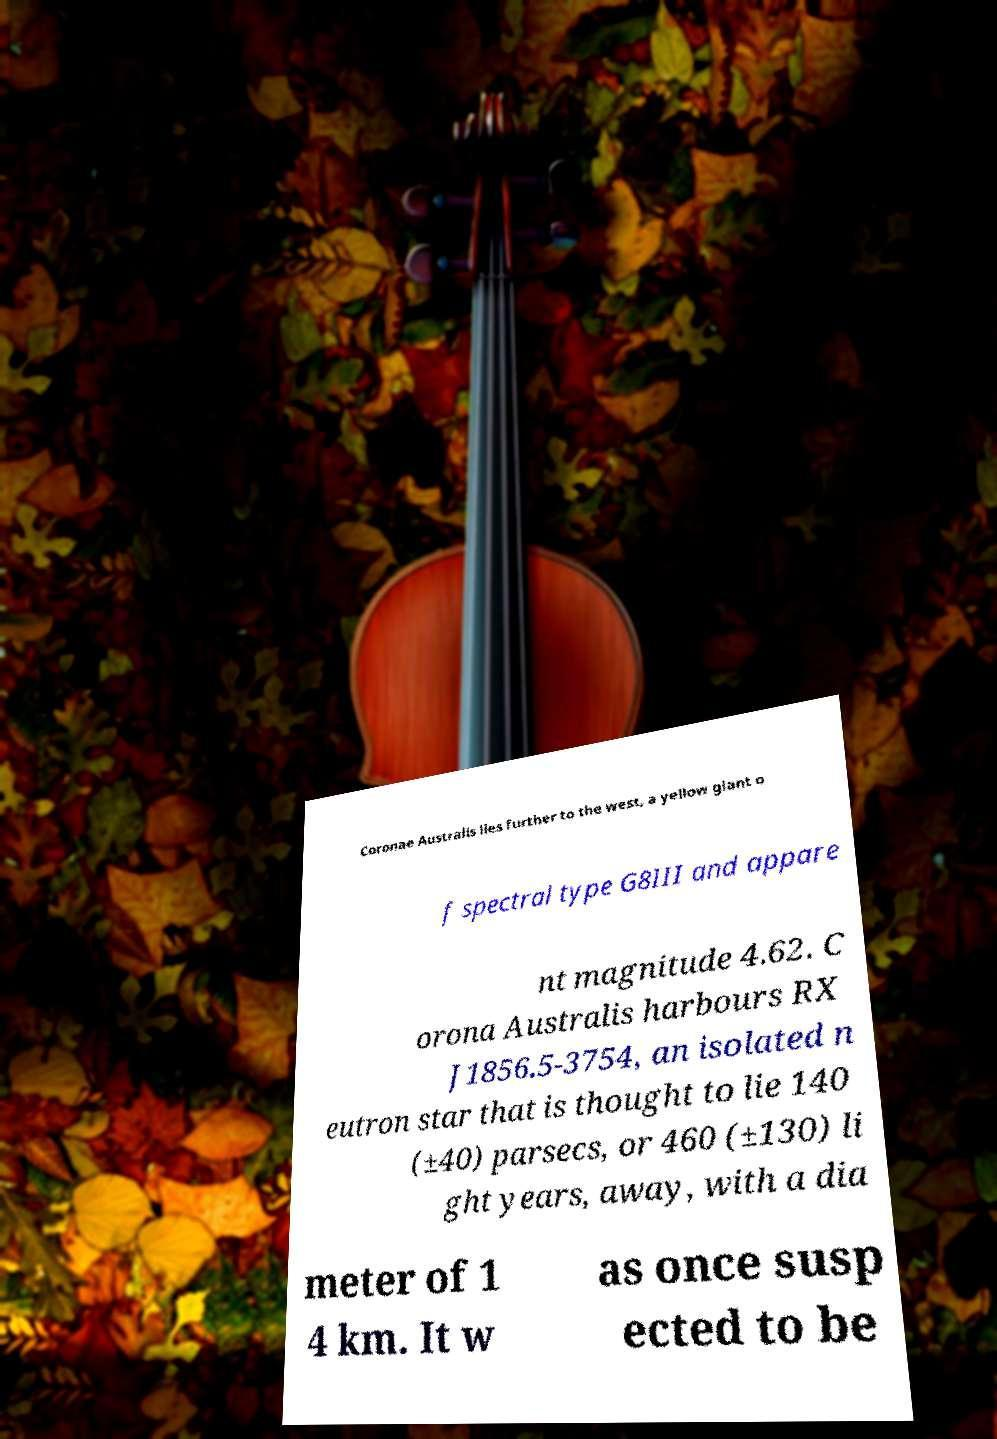Please identify and transcribe the text found in this image. Coronae Australis lies further to the west, a yellow giant o f spectral type G8III and appare nt magnitude 4.62. C orona Australis harbours RX J1856.5-3754, an isolated n eutron star that is thought to lie 140 (±40) parsecs, or 460 (±130) li ght years, away, with a dia meter of 1 4 km. It w as once susp ected to be 